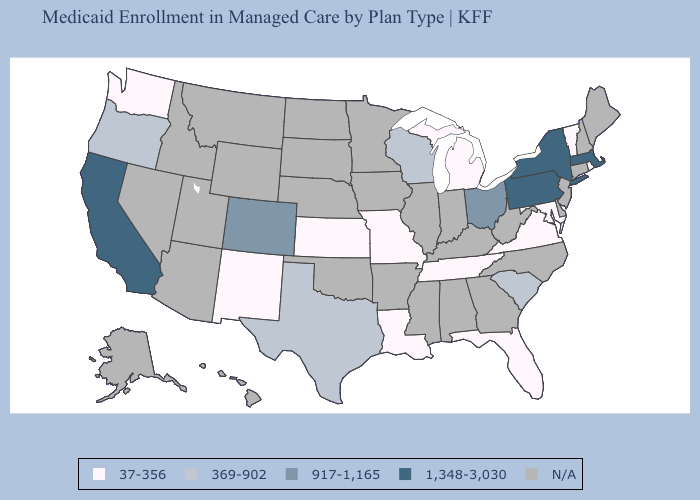What is the value of Montana?
Be succinct. N/A. Name the states that have a value in the range 1,348-3,030?
Be succinct. California, Massachusetts, New York, Pennsylvania. Which states have the lowest value in the West?
Write a very short answer. New Mexico, Washington. Name the states that have a value in the range 37-356?
Be succinct. Florida, Kansas, Louisiana, Maryland, Michigan, Missouri, New Mexico, Rhode Island, Tennessee, Vermont, Virginia, Washington. What is the value of Virginia?
Answer briefly. 37-356. Name the states that have a value in the range 1,348-3,030?
Keep it brief. California, Massachusetts, New York, Pennsylvania. What is the highest value in states that border Arkansas?
Answer briefly. 369-902. Which states have the lowest value in the USA?
Answer briefly. Florida, Kansas, Louisiana, Maryland, Michigan, Missouri, New Mexico, Rhode Island, Tennessee, Vermont, Virginia, Washington. What is the highest value in the West ?
Give a very brief answer. 1,348-3,030. Which states have the highest value in the USA?
Concise answer only. California, Massachusetts, New York, Pennsylvania. Name the states that have a value in the range 37-356?
Short answer required. Florida, Kansas, Louisiana, Maryland, Michigan, Missouri, New Mexico, Rhode Island, Tennessee, Vermont, Virginia, Washington. Name the states that have a value in the range 917-1,165?
Answer briefly. Colorado, Ohio. 